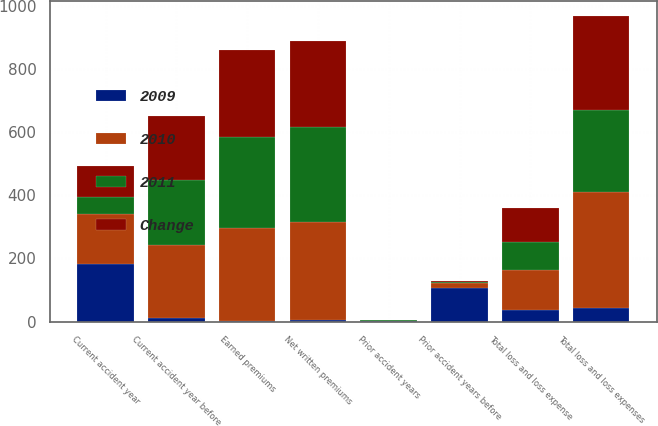Convert chart. <chart><loc_0><loc_0><loc_500><loc_500><stacked_bar_chart><ecel><fcel>Net written premiums<fcel>Earned premiums<fcel>Current accident year before<fcel>Current accident year<fcel>Prior accident years before<fcel>Total loss and loss expenses<fcel>Prior accident years<fcel>Total loss and loss expense<nl><fcel>2010<fcel>312<fcel>294<fcel>231<fcel>158<fcel>14<fcel>369<fcel>2<fcel>125.8<nl><fcel>2011<fcel>299<fcel>289<fcel>208<fcel>56<fcel>2<fcel>258<fcel>1.4<fcel>89<nl><fcel>Change<fcel>275<fcel>276<fcel>202<fcel>96<fcel>5<fcel>298<fcel>1.7<fcel>107.8<nl><fcel>2009<fcel>4<fcel>2<fcel>11<fcel>182<fcel>107.8<fcel>43<fcel>0.6<fcel>36.8<nl></chart> 